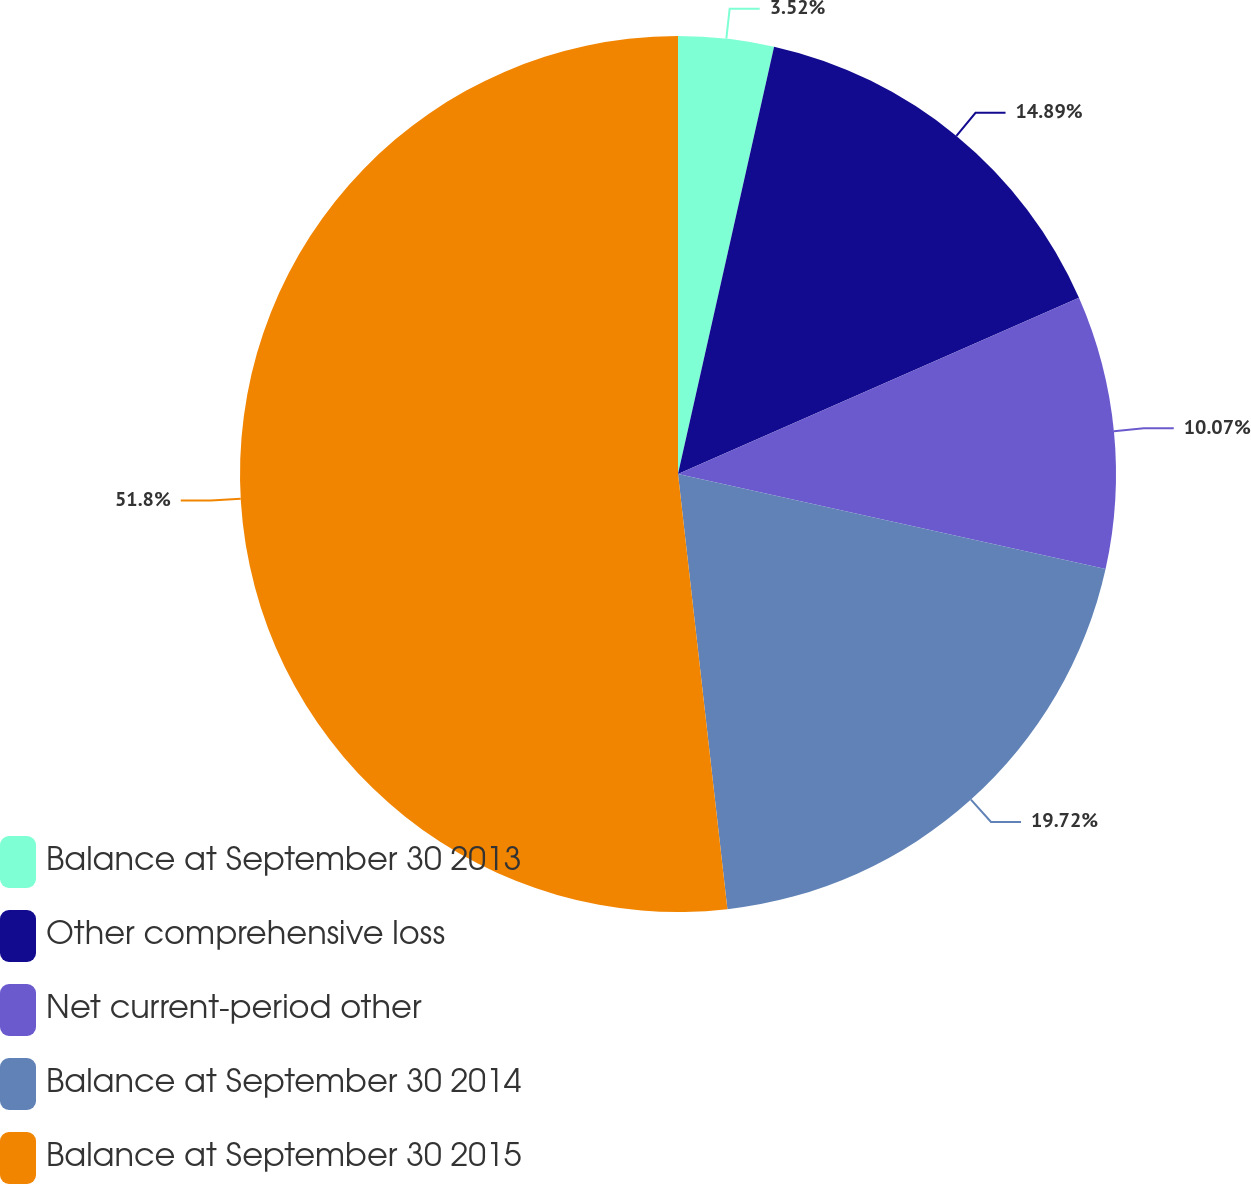Convert chart. <chart><loc_0><loc_0><loc_500><loc_500><pie_chart><fcel>Balance at September 30 2013<fcel>Other comprehensive loss<fcel>Net current-period other<fcel>Balance at September 30 2014<fcel>Balance at September 30 2015<nl><fcel>3.52%<fcel>14.89%<fcel>10.07%<fcel>19.72%<fcel>51.8%<nl></chart> 